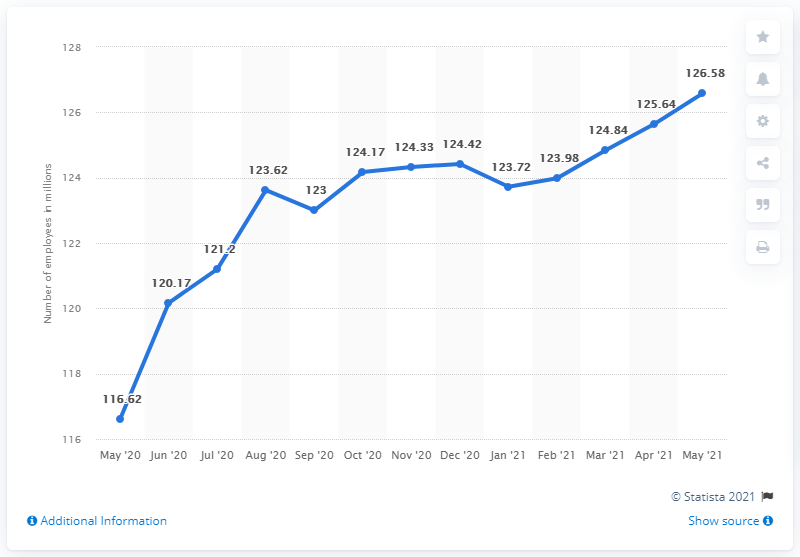Mention a couple of crucial points in this snapshot. In May 2021, there were approximately 126.58 full-time employees in the United States. In the months of September 2020 and January 2021, there was a decrease in the number of full-time employees in the United States compared to the previous month. As of May 2020, there were 116.62 full-time employees. June 2020 witnessed the steepest increase in the number of full-time employees in the United States. 